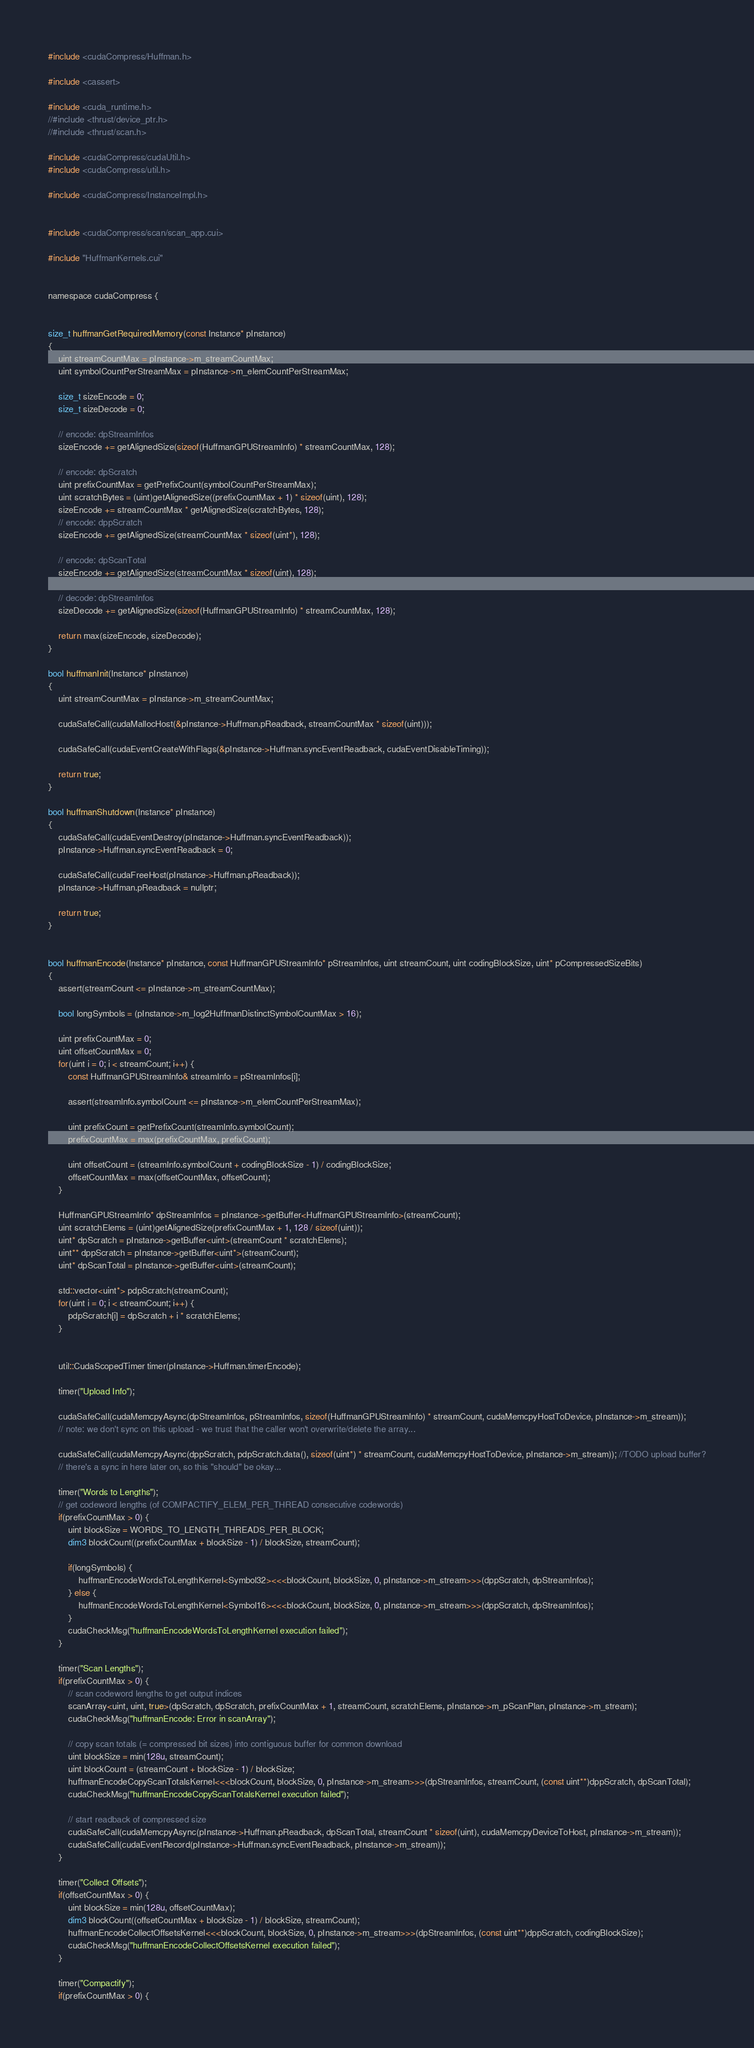<code> <loc_0><loc_0><loc_500><loc_500><_Cuda_>#include <cudaCompress/Huffman.h>

#include <cassert>

#include <cuda_runtime.h>
//#include <thrust/device_ptr.h>
//#include <thrust/scan.h>

#include <cudaCompress/cudaUtil.h>
#include <cudaCompress/util.h>

#include <cudaCompress/InstanceImpl.h>


#include <cudaCompress/scan/scan_app.cui>

#include "HuffmanKernels.cui"


namespace cudaCompress {


size_t huffmanGetRequiredMemory(const Instance* pInstance)
{
    uint streamCountMax = pInstance->m_streamCountMax;
    uint symbolCountPerStreamMax = pInstance->m_elemCountPerStreamMax;

    size_t sizeEncode = 0;
    size_t sizeDecode = 0;

    // encode: dpStreamInfos
    sizeEncode += getAlignedSize(sizeof(HuffmanGPUStreamInfo) * streamCountMax, 128);

    // encode: dpScratch
    uint prefixCountMax = getPrefixCount(symbolCountPerStreamMax);
    uint scratchBytes = (uint)getAlignedSize((prefixCountMax + 1) * sizeof(uint), 128);
    sizeEncode += streamCountMax * getAlignedSize(scratchBytes, 128);
    // encode: dppScratch
    sizeEncode += getAlignedSize(streamCountMax * sizeof(uint*), 128);

    // encode: dpScanTotal
    sizeEncode += getAlignedSize(streamCountMax * sizeof(uint), 128);

    // decode: dpStreamInfos
    sizeDecode += getAlignedSize(sizeof(HuffmanGPUStreamInfo) * streamCountMax, 128);

    return max(sizeEncode, sizeDecode);
}

bool huffmanInit(Instance* pInstance)
{
    uint streamCountMax = pInstance->m_streamCountMax;

    cudaSafeCall(cudaMallocHost(&pInstance->Huffman.pReadback, streamCountMax * sizeof(uint)));

    cudaSafeCall(cudaEventCreateWithFlags(&pInstance->Huffman.syncEventReadback, cudaEventDisableTiming));

    return true;
}

bool huffmanShutdown(Instance* pInstance)
{
    cudaSafeCall(cudaEventDestroy(pInstance->Huffman.syncEventReadback));
    pInstance->Huffman.syncEventReadback = 0;

    cudaSafeCall(cudaFreeHost(pInstance->Huffman.pReadback));
    pInstance->Huffman.pReadback = nullptr;

    return true;
}


bool huffmanEncode(Instance* pInstance, const HuffmanGPUStreamInfo* pStreamInfos, uint streamCount, uint codingBlockSize, uint* pCompressedSizeBits)
{
    assert(streamCount <= pInstance->m_streamCountMax);

    bool longSymbols = (pInstance->m_log2HuffmanDistinctSymbolCountMax > 16);

    uint prefixCountMax = 0;
    uint offsetCountMax = 0;
    for(uint i = 0; i < streamCount; i++) {
        const HuffmanGPUStreamInfo& streamInfo = pStreamInfos[i];

        assert(streamInfo.symbolCount <= pInstance->m_elemCountPerStreamMax);

        uint prefixCount = getPrefixCount(streamInfo.symbolCount);
        prefixCountMax = max(prefixCountMax, prefixCount);

        uint offsetCount = (streamInfo.symbolCount + codingBlockSize - 1) / codingBlockSize;
        offsetCountMax = max(offsetCountMax, offsetCount);
    }

    HuffmanGPUStreamInfo* dpStreamInfos = pInstance->getBuffer<HuffmanGPUStreamInfo>(streamCount);
    uint scratchElems = (uint)getAlignedSize(prefixCountMax + 1, 128 / sizeof(uint));
    uint* dpScratch = pInstance->getBuffer<uint>(streamCount * scratchElems);
    uint** dppScratch = pInstance->getBuffer<uint*>(streamCount);
    uint* dpScanTotal = pInstance->getBuffer<uint>(streamCount);

    std::vector<uint*> pdpScratch(streamCount);
    for(uint i = 0; i < streamCount; i++) {
        pdpScratch[i] = dpScratch + i * scratchElems;
    }


    util::CudaScopedTimer timer(pInstance->Huffman.timerEncode);

    timer("Upload Info");

    cudaSafeCall(cudaMemcpyAsync(dpStreamInfos, pStreamInfos, sizeof(HuffmanGPUStreamInfo) * streamCount, cudaMemcpyHostToDevice, pInstance->m_stream));
    // note: we don't sync on this upload - we trust that the caller won't overwrite/delete the array...

    cudaSafeCall(cudaMemcpyAsync(dppScratch, pdpScratch.data(), sizeof(uint*) * streamCount, cudaMemcpyHostToDevice, pInstance->m_stream)); //TODO upload buffer?
    // there's a sync in here later on, so this "should" be okay...

    timer("Words to Lengths");
    // get codeword lengths (of COMPACTIFY_ELEM_PER_THREAD consecutive codewords)
    if(prefixCountMax > 0) {
        uint blockSize = WORDS_TO_LENGTH_THREADS_PER_BLOCK;
        dim3 blockCount((prefixCountMax + blockSize - 1) / blockSize, streamCount);

        if(longSymbols) {
            huffmanEncodeWordsToLengthKernel<Symbol32><<<blockCount, blockSize, 0, pInstance->m_stream>>>(dppScratch, dpStreamInfos);
        } else {
            huffmanEncodeWordsToLengthKernel<Symbol16><<<blockCount, blockSize, 0, pInstance->m_stream>>>(dppScratch, dpStreamInfos);
        }
        cudaCheckMsg("huffmanEncodeWordsToLengthKernel execution failed");
    }

    timer("Scan Lengths");
    if(prefixCountMax > 0) {
        // scan codeword lengths to get output indices
        scanArray<uint, uint, true>(dpScratch, dpScratch, prefixCountMax + 1, streamCount, scratchElems, pInstance->m_pScanPlan, pInstance->m_stream);
        cudaCheckMsg("huffmanEncode: Error in scanArray");

        // copy scan totals (= compressed bit sizes) into contiguous buffer for common download
        uint blockSize = min(128u, streamCount);
        uint blockCount = (streamCount + blockSize - 1) / blockSize;
        huffmanEncodeCopyScanTotalsKernel<<<blockCount, blockSize, 0, pInstance->m_stream>>>(dpStreamInfos, streamCount, (const uint**)dppScratch, dpScanTotal);
        cudaCheckMsg("huffmanEncodeCopyScanTotalsKernel execution failed");

        // start readback of compressed size
        cudaSafeCall(cudaMemcpyAsync(pInstance->Huffman.pReadback, dpScanTotal, streamCount * sizeof(uint), cudaMemcpyDeviceToHost, pInstance->m_stream));
        cudaSafeCall(cudaEventRecord(pInstance->Huffman.syncEventReadback, pInstance->m_stream));
    }

    timer("Collect Offsets");
    if(offsetCountMax > 0) {
        uint blockSize = min(128u, offsetCountMax);
        dim3 blockCount((offsetCountMax + blockSize - 1) / blockSize, streamCount);
        huffmanEncodeCollectOffsetsKernel<<<blockCount, blockSize, 0, pInstance->m_stream>>>(dpStreamInfos, (const uint**)dppScratch, codingBlockSize);
        cudaCheckMsg("huffmanEncodeCollectOffsetsKernel execution failed");
    }

    timer("Compactify");
    if(prefixCountMax > 0) {</code> 